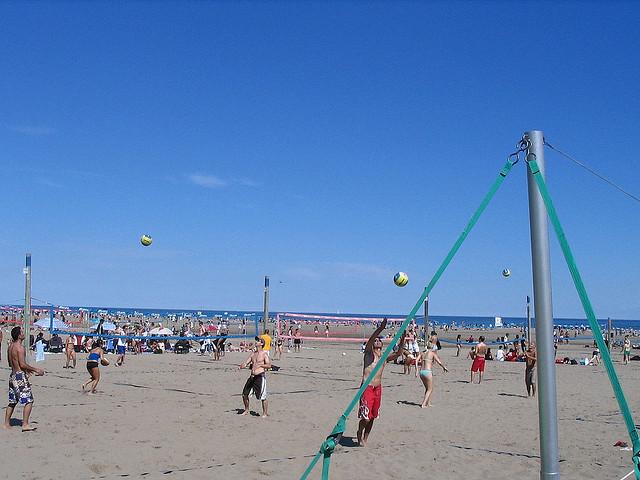Is the beach crowded?
Give a very brief answer. Yes. Is the beach crowded?
Quick response, please. Yes. What are these people playing?
Concise answer only. Volleyball. 